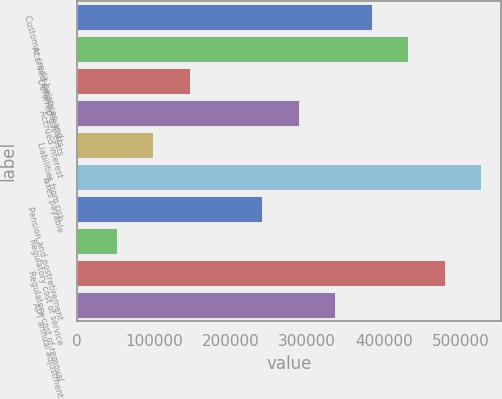Convert chart. <chart><loc_0><loc_0><loc_500><loc_500><bar_chart><fcel>Customer credit balances and<fcel>Accrued employee costs<fcel>Deferred gas costs<fcel>Accrued interest<fcel>Liabilities from risk<fcel>Taxes payable<fcel>Pension and postretirement<fcel>Regulatory cost of service<fcel>Regulatory cost of removal<fcel>APT annual adjustment<nl><fcel>384368<fcel>431935<fcel>146536<fcel>289235<fcel>98969.8<fcel>527067<fcel>241669<fcel>51403.4<fcel>479501<fcel>336802<nl></chart> 